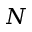<formula> <loc_0><loc_0><loc_500><loc_500>N</formula> 